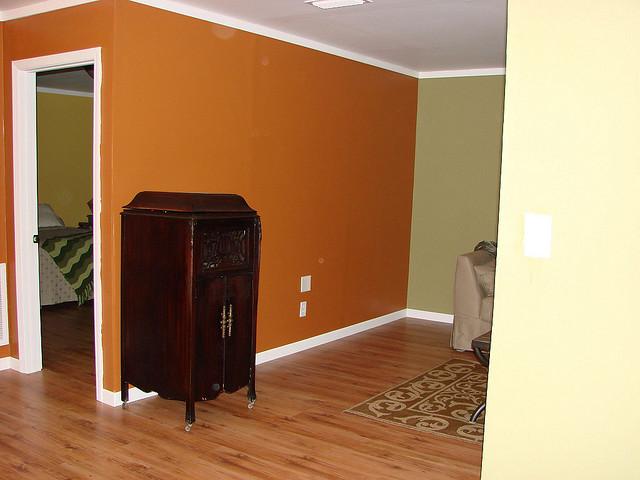What kind of room is this?
Keep it brief. Living room. What is orange in this photo?
Answer briefly. Wall. Is anyone in the picture?
Give a very brief answer. No. What color is the wall?
Concise answer only. Orange. 